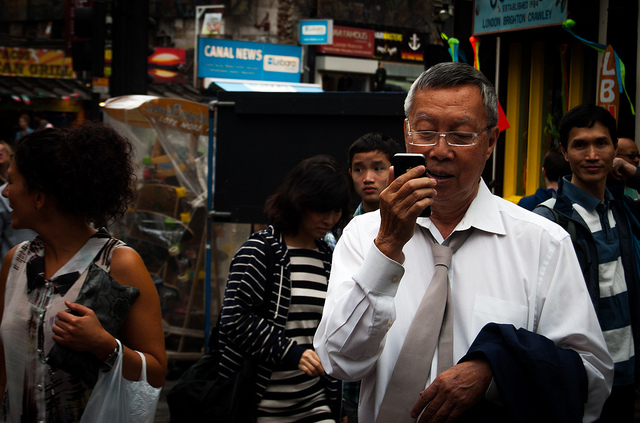<image>What credit card company is advertised in the background? It is unclear what credit card company is advertised in the background. It could be Mastercard, Visa or Chase. What animal print is on the  clutch purse that the woman is holding? I am unsure about the animal print on the clutch purse the woman is holding. It could be alligator, leopard, snake or no print at all. What credit card company is advertised in the background? I am not sure what credit card company is advertised in the background. It can be seen 'mastercard', 'visa', 'chase' or 'none'. What animal print is on the  clutch purse that the woman is holding? It is unknown what animal print is on the clutch purse that the woman is holding. 